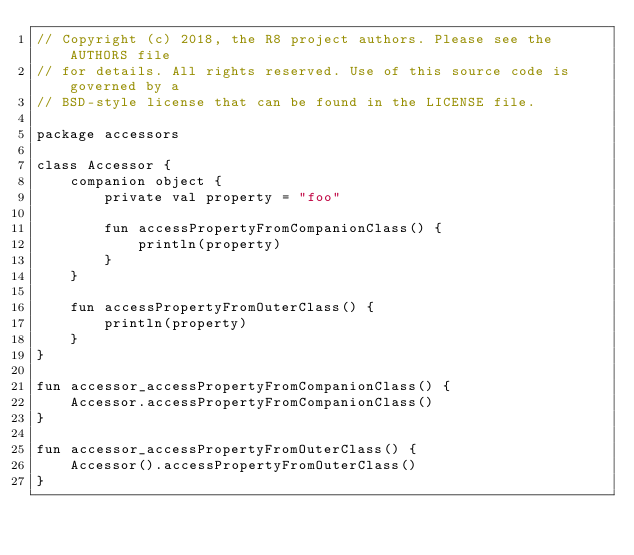Convert code to text. <code><loc_0><loc_0><loc_500><loc_500><_Kotlin_>// Copyright (c) 2018, the R8 project authors. Please see the AUTHORS file
// for details. All rights reserved. Use of this source code is governed by a
// BSD-style license that can be found in the LICENSE file.

package accessors

class Accessor {
    companion object {
        private val property = "foo"

        fun accessPropertyFromCompanionClass() {
            println(property)
        }
    }

    fun accessPropertyFromOuterClass() {
        println(property)
    }
}

fun accessor_accessPropertyFromCompanionClass() {
    Accessor.accessPropertyFromCompanionClass()
}

fun accessor_accessPropertyFromOuterClass() {
    Accessor().accessPropertyFromOuterClass()
}</code> 